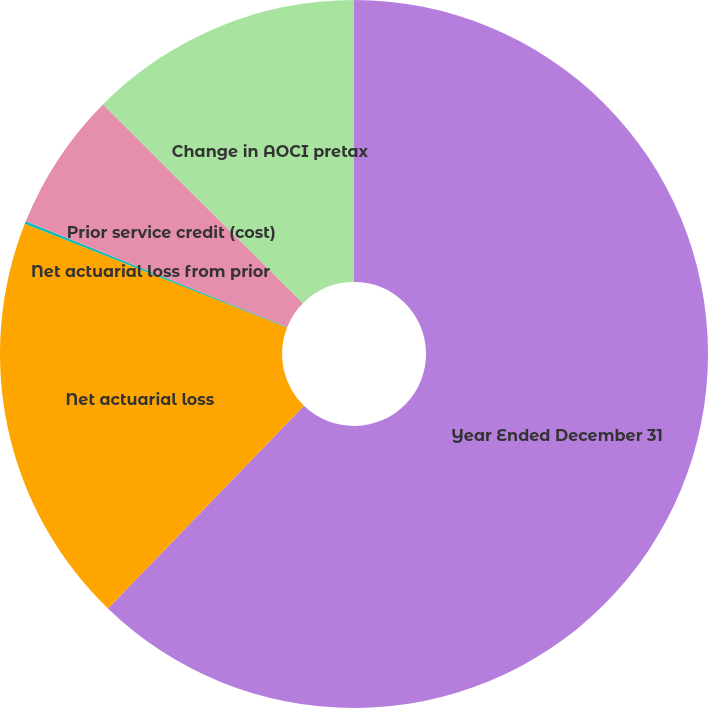<chart> <loc_0><loc_0><loc_500><loc_500><pie_chart><fcel>Year Ended December 31<fcel>Net actuarial loss<fcel>Net actuarial loss from prior<fcel>Prior service credit (cost)<fcel>Change in AOCI pretax<nl><fcel>62.24%<fcel>18.76%<fcel>0.12%<fcel>6.34%<fcel>12.55%<nl></chart> 